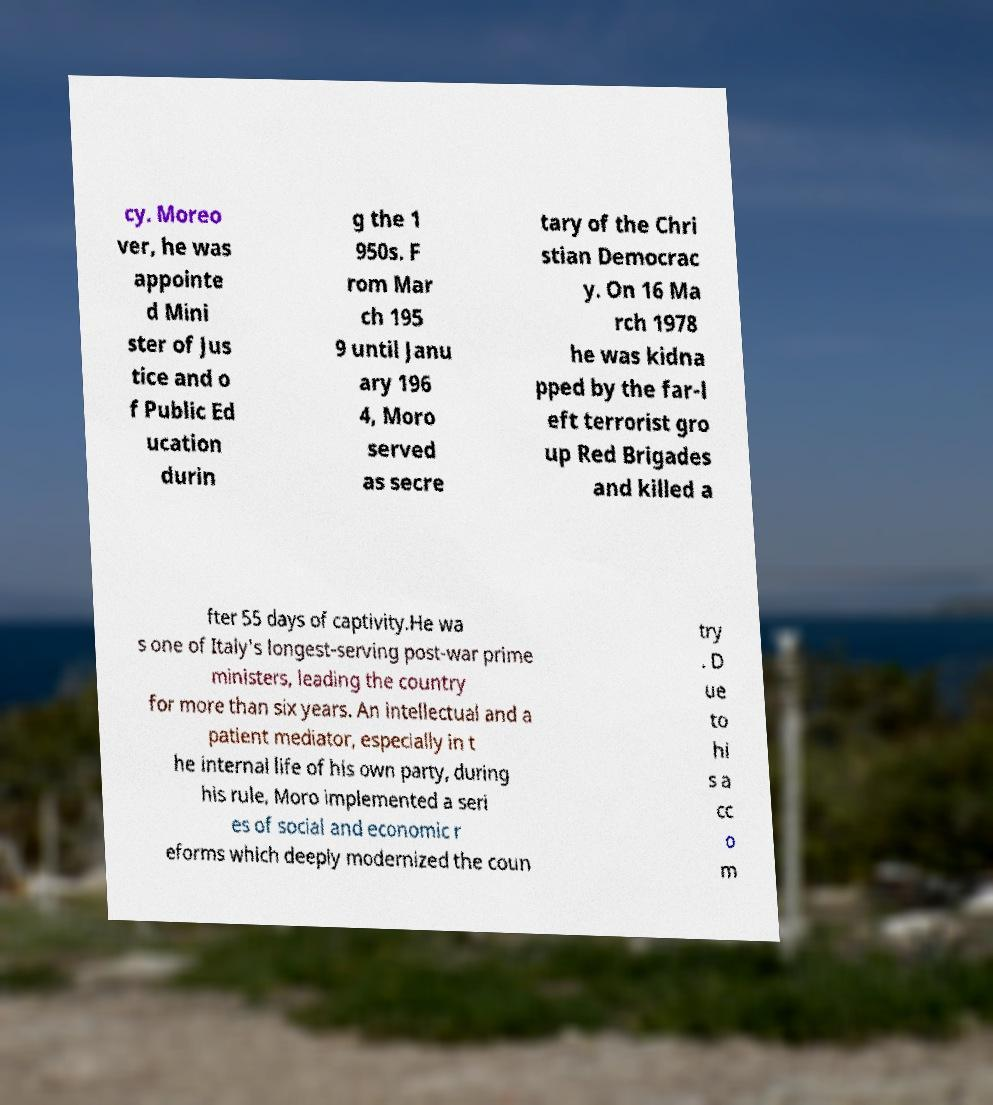Please read and relay the text visible in this image. What does it say? cy. Moreo ver, he was appointe d Mini ster of Jus tice and o f Public Ed ucation durin g the 1 950s. F rom Mar ch 195 9 until Janu ary 196 4, Moro served as secre tary of the Chri stian Democrac y. On 16 Ma rch 1978 he was kidna pped by the far-l eft terrorist gro up Red Brigades and killed a fter 55 days of captivity.He wa s one of Italy's longest-serving post-war prime ministers, leading the country for more than six years. An intellectual and a patient mediator, especially in t he internal life of his own party, during his rule, Moro implemented a seri es of social and economic r eforms which deeply modernized the coun try . D ue to hi s a cc o m 